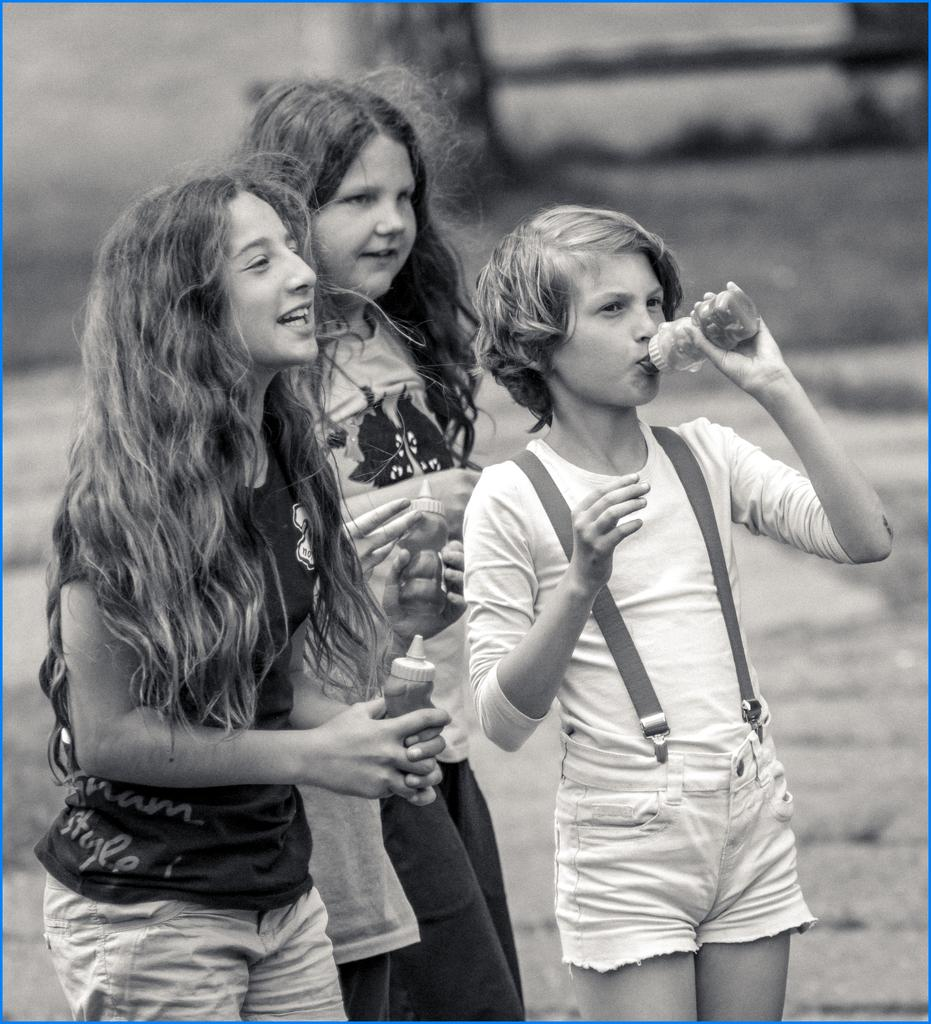What is the color scheme of the image? The image is black and white. Who is present in the image? There are kids in the image. What are the kids doing in the image? The kids are holding hands and holding bottles in their hands. Can you describe the background of the image? The background of the image is blurry. What type of coast can be seen in the background of the image? There is no coast visible in the image, as the background is blurry and does not show any specific landscape. What kind of haircut do the kids have in the image? The image is black and white, so it is difficult to determine the haircuts of the kids. Additionally, the focus of the image is on the kids holding hands and bottles, not their haircuts. 